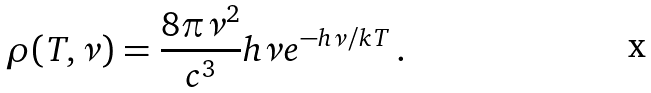<formula> <loc_0><loc_0><loc_500><loc_500>\rho ( T , \nu ) = \frac { 8 \pi \nu ^ { 2 } } { c ^ { 3 } } h \nu e ^ { - h \nu / k T } \, .</formula> 